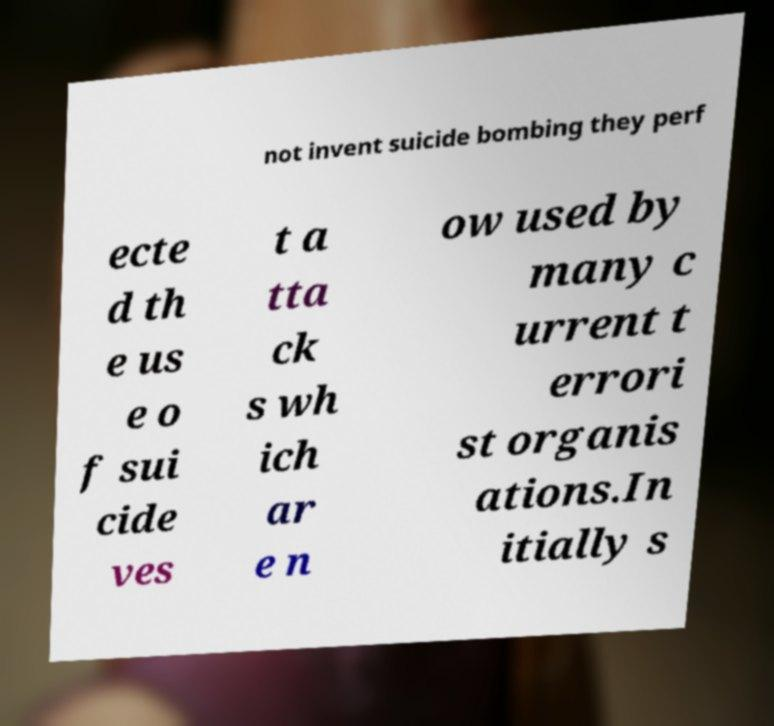Please identify and transcribe the text found in this image. not invent suicide bombing they perf ecte d th e us e o f sui cide ves t a tta ck s wh ich ar e n ow used by many c urrent t errori st organis ations.In itially s 